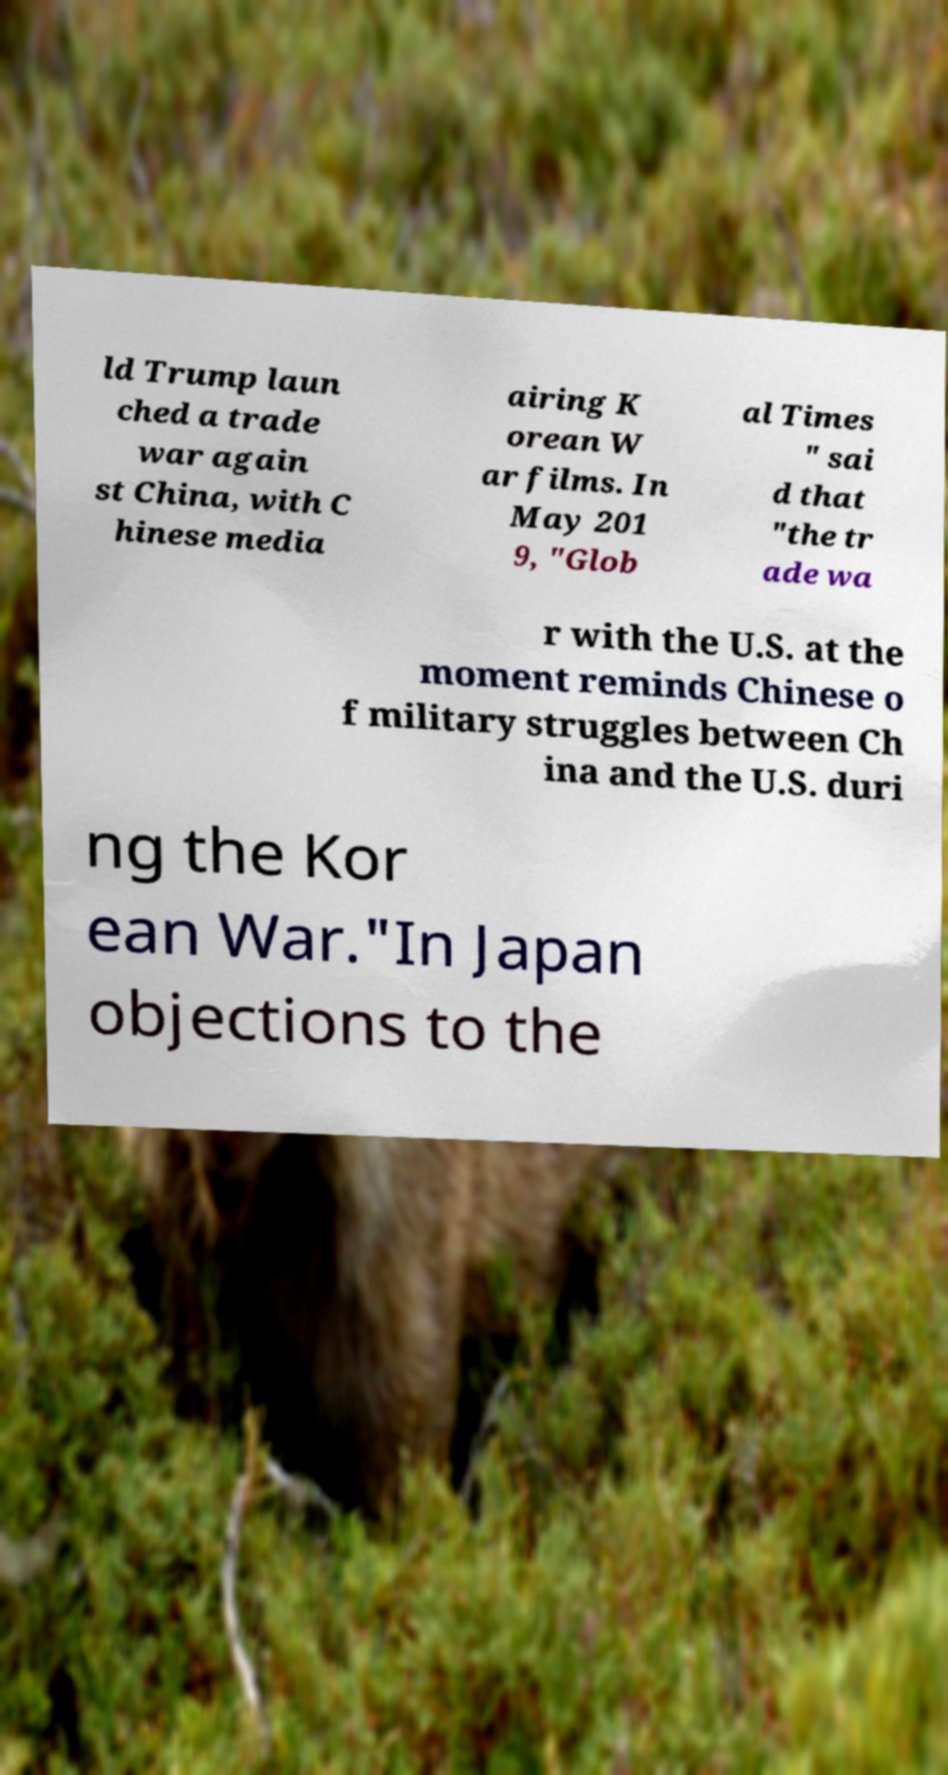Can you accurately transcribe the text from the provided image for me? ld Trump laun ched a trade war again st China, with C hinese media airing K orean W ar films. In May 201 9, "Glob al Times " sai d that "the tr ade wa r with the U.S. at the moment reminds Chinese o f military struggles between Ch ina and the U.S. duri ng the Kor ean War."In Japan objections to the 